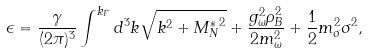Convert formula to latex. <formula><loc_0><loc_0><loc_500><loc_500>\epsilon = \frac { \gamma } { ( 2 \pi ) ^ { 3 } } \int ^ { k _ { F } } d ^ { 3 } k \sqrt { k ^ { 2 } + { M _ { N } ^ { * } } ^ { 2 } } + \frac { g _ { \omega } ^ { 2 } \rho _ { B } ^ { 2 } } { 2 m _ { \omega } ^ { 2 } } + \frac { 1 } { 2 } m _ { \sigma } ^ { 2 } \sigma ^ { 2 } ,</formula> 